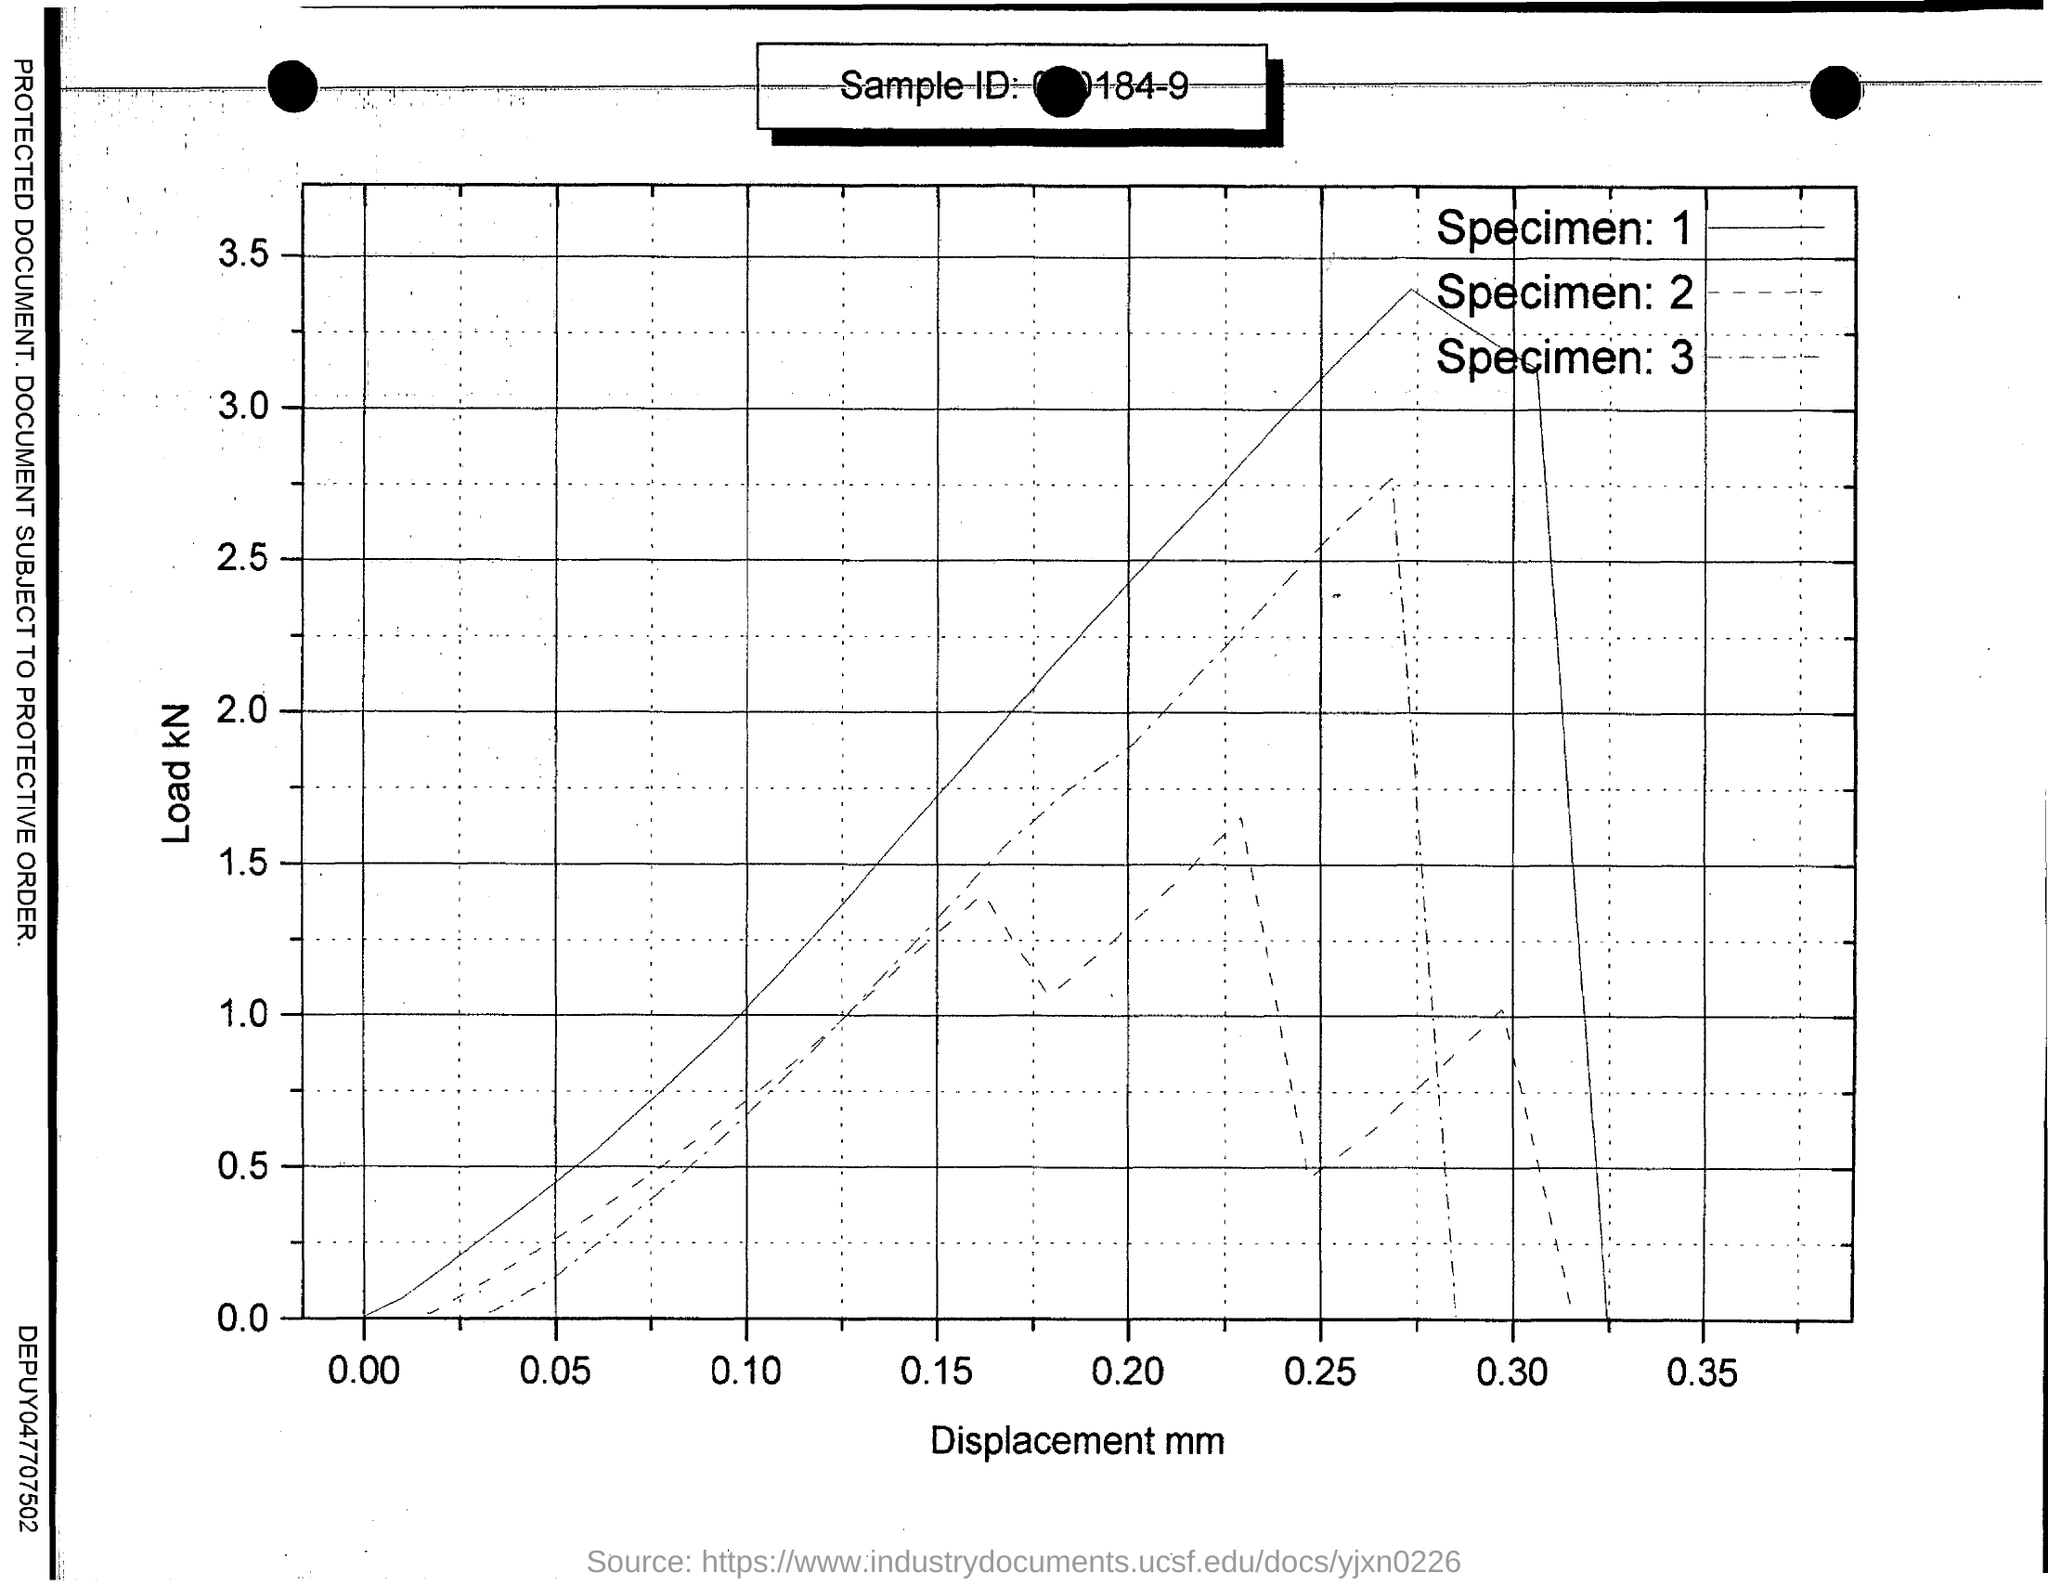Highlight a few significant elements in this photo. The displacement values, expressed in millimeters, are provided on the X-axis. The load, specified in kilonewtons (kN), is what is provided on the Y-axis. 